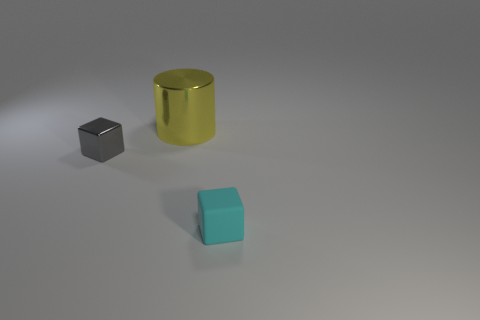Add 2 small gray shiny cubes. How many small gray shiny cubes exist? 3 Add 3 yellow objects. How many objects exist? 6 Subtract all gray blocks. How many blocks are left? 1 Subtract 0 blue blocks. How many objects are left? 3 Subtract all cylinders. How many objects are left? 2 Subtract 1 cylinders. How many cylinders are left? 0 Subtract all brown cylinders. Subtract all cyan blocks. How many cylinders are left? 1 Subtract all brown blocks. How many cyan cylinders are left? 0 Subtract all big matte blocks. Subtract all tiny objects. How many objects are left? 1 Add 3 small blocks. How many small blocks are left? 5 